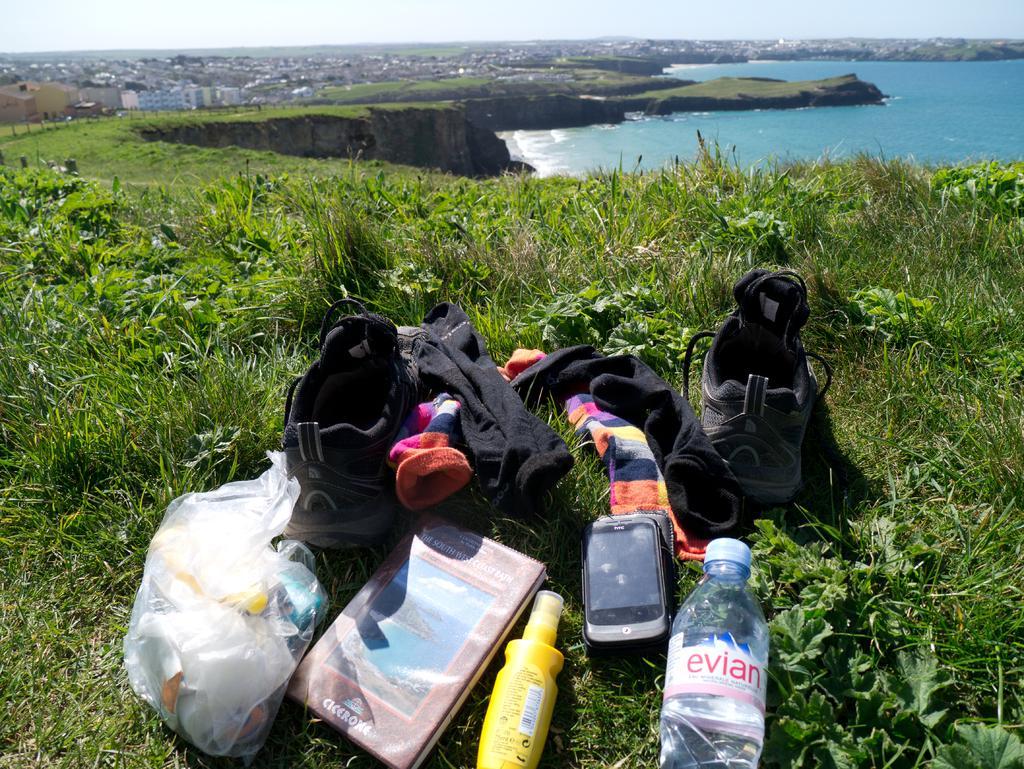Can you describe this image briefly? In this picture we can see two shoe and one water bottle, one mobile phone and some of the clothes here. We can see grass and water here, we can see in the background there is a sky and some of the buildings here. 